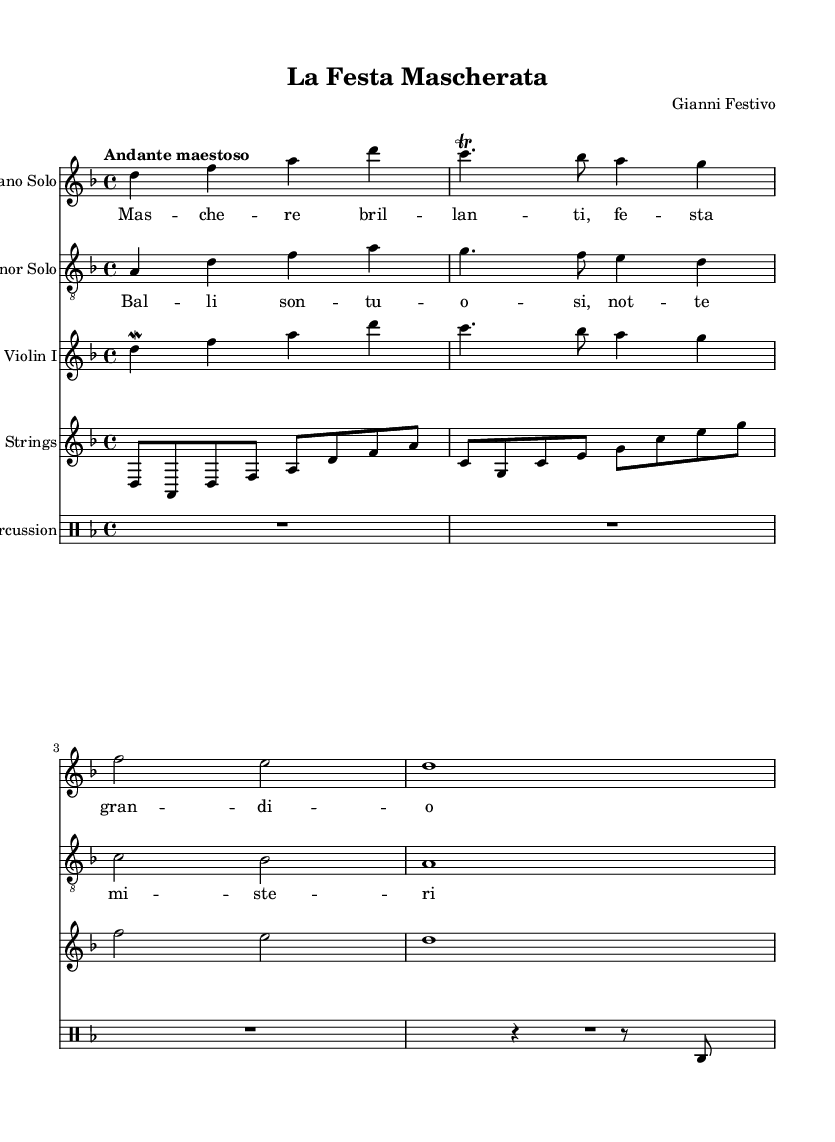What is the key signature of this music? The key signature is indicated by the presence of the flat sign in the music notation. In this piece, it is set to D minor, which has one flat (B flat).
Answer: D minor What is the time signature of this piece? The time signature is located at the beginning of the score, presented as a fraction. Here, it shows 4 over 4, indicating that there are four beats in each measure.
Answer: 4/4 What is the tempo marking for the piece? The tempo is indicated by the text "Andante maestoso" near the top of the score, specifying how fast the music should be played, generally at a moderate pace with a majestic feel.
Answer: Andante maestoso How many measures does the soprano solo contain? By counting the individual segments separated by vertical lines (bar lines) in the soprano solo section, there are a total of 4 measures represented.
Answer: 4 What instruments are included in the score? The instruments are listed at the beginning of each staff section. This score includes Soprano Solo, Tenor Solo, Violin I, Strings, and Percussion, reflecting the diverse orchestration typical in opera.
Answer: Soprano Solo, Tenor Solo, Violin I, Strings, Percussion What is the title of this opera? The title is found at the top of the score under the header section and indicates the name of the opera, which is "La Festa Mascherata."
Answer: La Festa Mascherata Which vocal part is featured with a trill? The specific vocal part with a trill is indicated in the music notation, which shows the trilling note in the soprano's section where it occurs. Therefore, it is the Soprano Solo part that features the trill.
Answer: Soprano Solo 